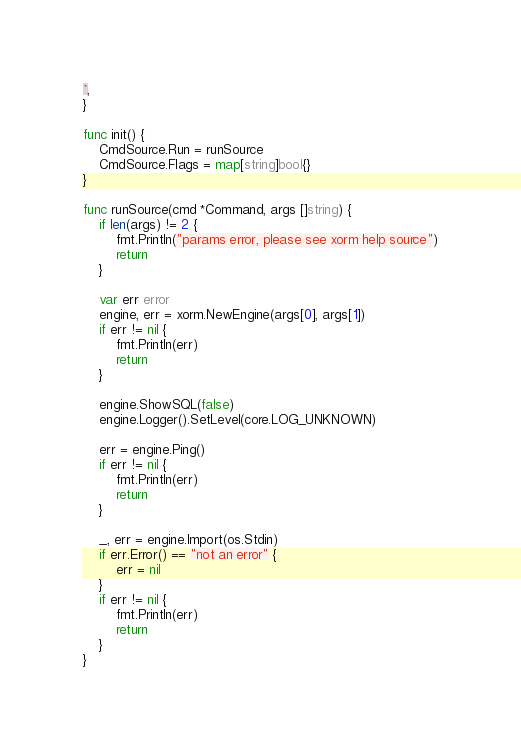Convert code to text. <code><loc_0><loc_0><loc_500><loc_500><_Go_>`,
}

func init() {
	CmdSource.Run = runSource
	CmdSource.Flags = map[string]bool{}
}

func runSource(cmd *Command, args []string) {
	if len(args) != 2 {
		fmt.Println("params error, please see xorm help source")
		return
	}

	var err error
	engine, err = xorm.NewEngine(args[0], args[1])
	if err != nil {
		fmt.Println(err)
		return
	}

	engine.ShowSQL(false)
	engine.Logger().SetLevel(core.LOG_UNKNOWN)

	err = engine.Ping()
	if err != nil {
		fmt.Println(err)
		return
	}

	_, err = engine.Import(os.Stdin)
	if err.Error() == "not an error" {
		err = nil
	}
	if err != nil {
		fmt.Println(err)
		return
	}
}
</code> 